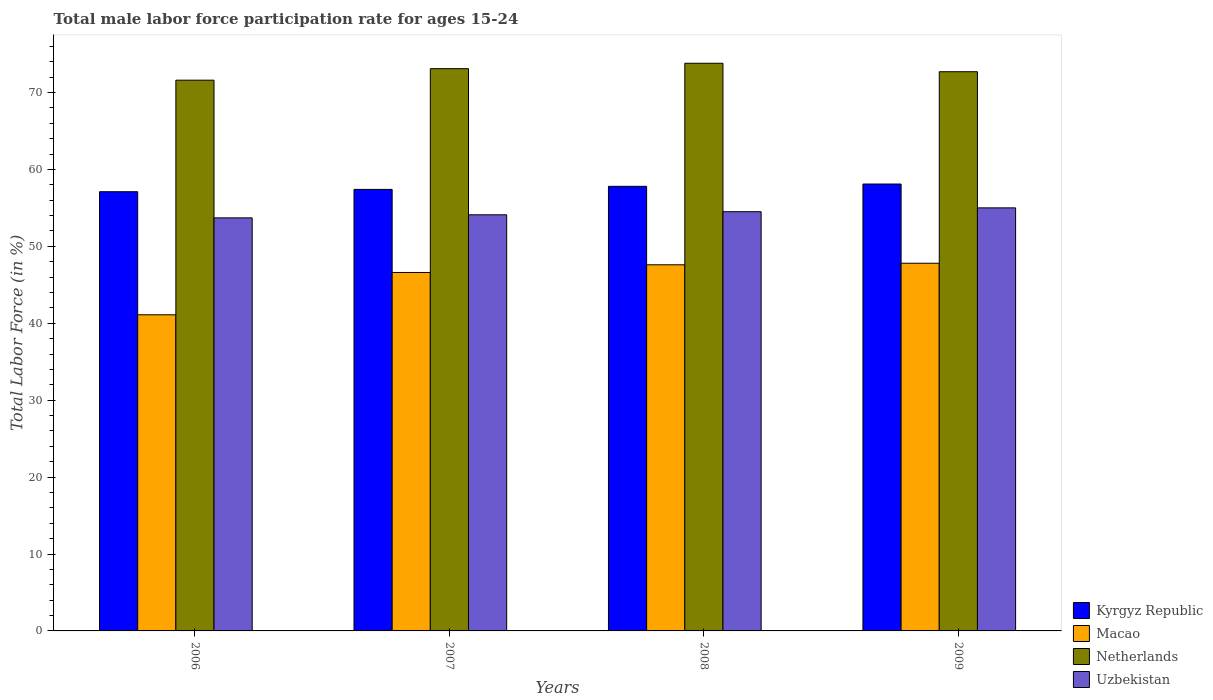How many groups of bars are there?
Your answer should be compact. 4. Are the number of bars on each tick of the X-axis equal?
Make the answer very short. Yes. How many bars are there on the 4th tick from the left?
Ensure brevity in your answer.  4. How many bars are there on the 3rd tick from the right?
Offer a terse response. 4. In how many cases, is the number of bars for a given year not equal to the number of legend labels?
Your answer should be very brief. 0. What is the male labor force participation rate in Netherlands in 2007?
Your answer should be compact. 73.1. Across all years, what is the maximum male labor force participation rate in Macao?
Provide a short and direct response. 47.8. Across all years, what is the minimum male labor force participation rate in Uzbekistan?
Make the answer very short. 53.7. In which year was the male labor force participation rate in Uzbekistan minimum?
Offer a terse response. 2006. What is the total male labor force participation rate in Uzbekistan in the graph?
Make the answer very short. 217.3. What is the difference between the male labor force participation rate in Kyrgyz Republic in 2006 and that in 2007?
Your response must be concise. -0.3. What is the difference between the male labor force participation rate in Uzbekistan in 2007 and the male labor force participation rate in Netherlands in 2006?
Keep it short and to the point. -17.5. What is the average male labor force participation rate in Uzbekistan per year?
Make the answer very short. 54.32. In the year 2006, what is the difference between the male labor force participation rate in Kyrgyz Republic and male labor force participation rate in Netherlands?
Offer a very short reply. -14.5. In how many years, is the male labor force participation rate in Macao greater than 40 %?
Provide a succinct answer. 4. What is the ratio of the male labor force participation rate in Netherlands in 2006 to that in 2007?
Ensure brevity in your answer.  0.98. Is the male labor force participation rate in Kyrgyz Republic in 2006 less than that in 2009?
Offer a very short reply. Yes. Is the difference between the male labor force participation rate in Kyrgyz Republic in 2006 and 2008 greater than the difference between the male labor force participation rate in Netherlands in 2006 and 2008?
Keep it short and to the point. Yes. What is the difference between the highest and the second highest male labor force participation rate in Macao?
Your answer should be compact. 0.2. What is the difference between the highest and the lowest male labor force participation rate in Uzbekistan?
Your response must be concise. 1.3. Is the sum of the male labor force participation rate in Macao in 2007 and 2008 greater than the maximum male labor force participation rate in Netherlands across all years?
Your answer should be compact. Yes. What does the 4th bar from the left in 2006 represents?
Make the answer very short. Uzbekistan. How many bars are there?
Give a very brief answer. 16. Are all the bars in the graph horizontal?
Give a very brief answer. No. Does the graph contain grids?
Make the answer very short. No. What is the title of the graph?
Provide a succinct answer. Total male labor force participation rate for ages 15-24. Does "Rwanda" appear as one of the legend labels in the graph?
Keep it short and to the point. No. What is the label or title of the Y-axis?
Ensure brevity in your answer.  Total Labor Force (in %). What is the Total Labor Force (in %) in Kyrgyz Republic in 2006?
Offer a terse response. 57.1. What is the Total Labor Force (in %) in Macao in 2006?
Ensure brevity in your answer.  41.1. What is the Total Labor Force (in %) of Netherlands in 2006?
Provide a succinct answer. 71.6. What is the Total Labor Force (in %) in Uzbekistan in 2006?
Offer a terse response. 53.7. What is the Total Labor Force (in %) in Kyrgyz Republic in 2007?
Make the answer very short. 57.4. What is the Total Labor Force (in %) in Macao in 2007?
Your answer should be very brief. 46.6. What is the Total Labor Force (in %) of Netherlands in 2007?
Your answer should be compact. 73.1. What is the Total Labor Force (in %) in Uzbekistan in 2007?
Offer a terse response. 54.1. What is the Total Labor Force (in %) in Kyrgyz Republic in 2008?
Make the answer very short. 57.8. What is the Total Labor Force (in %) in Macao in 2008?
Keep it short and to the point. 47.6. What is the Total Labor Force (in %) in Netherlands in 2008?
Your response must be concise. 73.8. What is the Total Labor Force (in %) of Uzbekistan in 2008?
Offer a very short reply. 54.5. What is the Total Labor Force (in %) in Kyrgyz Republic in 2009?
Your answer should be very brief. 58.1. What is the Total Labor Force (in %) of Macao in 2009?
Make the answer very short. 47.8. What is the Total Labor Force (in %) of Netherlands in 2009?
Offer a very short reply. 72.7. What is the Total Labor Force (in %) in Uzbekistan in 2009?
Give a very brief answer. 55. Across all years, what is the maximum Total Labor Force (in %) in Kyrgyz Republic?
Provide a succinct answer. 58.1. Across all years, what is the maximum Total Labor Force (in %) of Macao?
Give a very brief answer. 47.8. Across all years, what is the maximum Total Labor Force (in %) in Netherlands?
Provide a succinct answer. 73.8. Across all years, what is the minimum Total Labor Force (in %) in Kyrgyz Republic?
Ensure brevity in your answer.  57.1. Across all years, what is the minimum Total Labor Force (in %) of Macao?
Your response must be concise. 41.1. Across all years, what is the minimum Total Labor Force (in %) of Netherlands?
Provide a succinct answer. 71.6. Across all years, what is the minimum Total Labor Force (in %) in Uzbekistan?
Make the answer very short. 53.7. What is the total Total Labor Force (in %) in Kyrgyz Republic in the graph?
Your answer should be very brief. 230.4. What is the total Total Labor Force (in %) of Macao in the graph?
Your response must be concise. 183.1. What is the total Total Labor Force (in %) of Netherlands in the graph?
Give a very brief answer. 291.2. What is the total Total Labor Force (in %) of Uzbekistan in the graph?
Your answer should be compact. 217.3. What is the difference between the Total Labor Force (in %) in Uzbekistan in 2006 and that in 2007?
Ensure brevity in your answer.  -0.4. What is the difference between the Total Labor Force (in %) of Kyrgyz Republic in 2006 and that in 2008?
Offer a very short reply. -0.7. What is the difference between the Total Labor Force (in %) of Macao in 2006 and that in 2008?
Your answer should be very brief. -6.5. What is the difference between the Total Labor Force (in %) of Uzbekistan in 2006 and that in 2008?
Keep it short and to the point. -0.8. What is the difference between the Total Labor Force (in %) of Kyrgyz Republic in 2006 and that in 2009?
Offer a very short reply. -1. What is the difference between the Total Labor Force (in %) in Macao in 2006 and that in 2009?
Make the answer very short. -6.7. What is the difference between the Total Labor Force (in %) in Kyrgyz Republic in 2007 and that in 2008?
Offer a very short reply. -0.4. What is the difference between the Total Labor Force (in %) of Netherlands in 2007 and that in 2008?
Your answer should be very brief. -0.7. What is the difference between the Total Labor Force (in %) of Uzbekistan in 2007 and that in 2008?
Offer a very short reply. -0.4. What is the difference between the Total Labor Force (in %) in Kyrgyz Republic in 2007 and that in 2009?
Give a very brief answer. -0.7. What is the difference between the Total Labor Force (in %) in Macao in 2007 and that in 2009?
Give a very brief answer. -1.2. What is the difference between the Total Labor Force (in %) of Uzbekistan in 2007 and that in 2009?
Offer a terse response. -0.9. What is the difference between the Total Labor Force (in %) of Netherlands in 2008 and that in 2009?
Ensure brevity in your answer.  1.1. What is the difference between the Total Labor Force (in %) of Uzbekistan in 2008 and that in 2009?
Ensure brevity in your answer.  -0.5. What is the difference between the Total Labor Force (in %) in Kyrgyz Republic in 2006 and the Total Labor Force (in %) in Netherlands in 2007?
Offer a terse response. -16. What is the difference between the Total Labor Force (in %) in Macao in 2006 and the Total Labor Force (in %) in Netherlands in 2007?
Your answer should be compact. -32. What is the difference between the Total Labor Force (in %) of Macao in 2006 and the Total Labor Force (in %) of Uzbekistan in 2007?
Give a very brief answer. -13. What is the difference between the Total Labor Force (in %) in Kyrgyz Republic in 2006 and the Total Labor Force (in %) in Netherlands in 2008?
Ensure brevity in your answer.  -16.7. What is the difference between the Total Labor Force (in %) in Macao in 2006 and the Total Labor Force (in %) in Netherlands in 2008?
Ensure brevity in your answer.  -32.7. What is the difference between the Total Labor Force (in %) in Macao in 2006 and the Total Labor Force (in %) in Uzbekistan in 2008?
Keep it short and to the point. -13.4. What is the difference between the Total Labor Force (in %) of Kyrgyz Republic in 2006 and the Total Labor Force (in %) of Netherlands in 2009?
Your answer should be very brief. -15.6. What is the difference between the Total Labor Force (in %) of Macao in 2006 and the Total Labor Force (in %) of Netherlands in 2009?
Provide a succinct answer. -31.6. What is the difference between the Total Labor Force (in %) in Macao in 2006 and the Total Labor Force (in %) in Uzbekistan in 2009?
Ensure brevity in your answer.  -13.9. What is the difference between the Total Labor Force (in %) in Kyrgyz Republic in 2007 and the Total Labor Force (in %) in Netherlands in 2008?
Your response must be concise. -16.4. What is the difference between the Total Labor Force (in %) in Macao in 2007 and the Total Labor Force (in %) in Netherlands in 2008?
Ensure brevity in your answer.  -27.2. What is the difference between the Total Labor Force (in %) in Macao in 2007 and the Total Labor Force (in %) in Uzbekistan in 2008?
Your response must be concise. -7.9. What is the difference between the Total Labor Force (in %) of Kyrgyz Republic in 2007 and the Total Labor Force (in %) of Netherlands in 2009?
Provide a short and direct response. -15.3. What is the difference between the Total Labor Force (in %) in Macao in 2007 and the Total Labor Force (in %) in Netherlands in 2009?
Give a very brief answer. -26.1. What is the difference between the Total Labor Force (in %) of Netherlands in 2007 and the Total Labor Force (in %) of Uzbekistan in 2009?
Keep it short and to the point. 18.1. What is the difference between the Total Labor Force (in %) of Kyrgyz Republic in 2008 and the Total Labor Force (in %) of Macao in 2009?
Your answer should be very brief. 10. What is the difference between the Total Labor Force (in %) of Kyrgyz Republic in 2008 and the Total Labor Force (in %) of Netherlands in 2009?
Make the answer very short. -14.9. What is the difference between the Total Labor Force (in %) in Macao in 2008 and the Total Labor Force (in %) in Netherlands in 2009?
Your response must be concise. -25.1. What is the difference between the Total Labor Force (in %) in Macao in 2008 and the Total Labor Force (in %) in Uzbekistan in 2009?
Ensure brevity in your answer.  -7.4. What is the average Total Labor Force (in %) of Kyrgyz Republic per year?
Ensure brevity in your answer.  57.6. What is the average Total Labor Force (in %) of Macao per year?
Provide a succinct answer. 45.77. What is the average Total Labor Force (in %) of Netherlands per year?
Offer a very short reply. 72.8. What is the average Total Labor Force (in %) in Uzbekistan per year?
Give a very brief answer. 54.33. In the year 2006, what is the difference between the Total Labor Force (in %) of Kyrgyz Republic and Total Labor Force (in %) of Macao?
Give a very brief answer. 16. In the year 2006, what is the difference between the Total Labor Force (in %) in Macao and Total Labor Force (in %) in Netherlands?
Ensure brevity in your answer.  -30.5. In the year 2006, what is the difference between the Total Labor Force (in %) of Macao and Total Labor Force (in %) of Uzbekistan?
Offer a very short reply. -12.6. In the year 2007, what is the difference between the Total Labor Force (in %) of Kyrgyz Republic and Total Labor Force (in %) of Macao?
Provide a succinct answer. 10.8. In the year 2007, what is the difference between the Total Labor Force (in %) of Kyrgyz Republic and Total Labor Force (in %) of Netherlands?
Provide a succinct answer. -15.7. In the year 2007, what is the difference between the Total Labor Force (in %) of Macao and Total Labor Force (in %) of Netherlands?
Your answer should be very brief. -26.5. In the year 2008, what is the difference between the Total Labor Force (in %) in Kyrgyz Republic and Total Labor Force (in %) in Macao?
Your answer should be very brief. 10.2. In the year 2008, what is the difference between the Total Labor Force (in %) of Kyrgyz Republic and Total Labor Force (in %) of Netherlands?
Keep it short and to the point. -16. In the year 2008, what is the difference between the Total Labor Force (in %) in Macao and Total Labor Force (in %) in Netherlands?
Offer a very short reply. -26.2. In the year 2008, what is the difference between the Total Labor Force (in %) of Macao and Total Labor Force (in %) of Uzbekistan?
Provide a succinct answer. -6.9. In the year 2008, what is the difference between the Total Labor Force (in %) in Netherlands and Total Labor Force (in %) in Uzbekistan?
Keep it short and to the point. 19.3. In the year 2009, what is the difference between the Total Labor Force (in %) of Kyrgyz Republic and Total Labor Force (in %) of Netherlands?
Provide a succinct answer. -14.6. In the year 2009, what is the difference between the Total Labor Force (in %) in Kyrgyz Republic and Total Labor Force (in %) in Uzbekistan?
Give a very brief answer. 3.1. In the year 2009, what is the difference between the Total Labor Force (in %) in Macao and Total Labor Force (in %) in Netherlands?
Make the answer very short. -24.9. In the year 2009, what is the difference between the Total Labor Force (in %) in Macao and Total Labor Force (in %) in Uzbekistan?
Offer a very short reply. -7.2. In the year 2009, what is the difference between the Total Labor Force (in %) in Netherlands and Total Labor Force (in %) in Uzbekistan?
Your response must be concise. 17.7. What is the ratio of the Total Labor Force (in %) of Macao in 2006 to that in 2007?
Your answer should be very brief. 0.88. What is the ratio of the Total Labor Force (in %) in Netherlands in 2006 to that in 2007?
Make the answer very short. 0.98. What is the ratio of the Total Labor Force (in %) in Uzbekistan in 2006 to that in 2007?
Make the answer very short. 0.99. What is the ratio of the Total Labor Force (in %) of Kyrgyz Republic in 2006 to that in 2008?
Keep it short and to the point. 0.99. What is the ratio of the Total Labor Force (in %) in Macao in 2006 to that in 2008?
Your response must be concise. 0.86. What is the ratio of the Total Labor Force (in %) in Netherlands in 2006 to that in 2008?
Provide a succinct answer. 0.97. What is the ratio of the Total Labor Force (in %) of Uzbekistan in 2006 to that in 2008?
Provide a succinct answer. 0.99. What is the ratio of the Total Labor Force (in %) of Kyrgyz Republic in 2006 to that in 2009?
Offer a very short reply. 0.98. What is the ratio of the Total Labor Force (in %) of Macao in 2006 to that in 2009?
Offer a terse response. 0.86. What is the ratio of the Total Labor Force (in %) of Netherlands in 2006 to that in 2009?
Your response must be concise. 0.98. What is the ratio of the Total Labor Force (in %) in Uzbekistan in 2006 to that in 2009?
Provide a succinct answer. 0.98. What is the ratio of the Total Labor Force (in %) in Netherlands in 2007 to that in 2008?
Offer a very short reply. 0.99. What is the ratio of the Total Labor Force (in %) of Kyrgyz Republic in 2007 to that in 2009?
Your answer should be very brief. 0.99. What is the ratio of the Total Labor Force (in %) in Macao in 2007 to that in 2009?
Keep it short and to the point. 0.97. What is the ratio of the Total Labor Force (in %) of Uzbekistan in 2007 to that in 2009?
Your response must be concise. 0.98. What is the ratio of the Total Labor Force (in %) of Kyrgyz Republic in 2008 to that in 2009?
Ensure brevity in your answer.  0.99. What is the ratio of the Total Labor Force (in %) in Macao in 2008 to that in 2009?
Keep it short and to the point. 1. What is the ratio of the Total Labor Force (in %) in Netherlands in 2008 to that in 2009?
Your response must be concise. 1.02. What is the ratio of the Total Labor Force (in %) of Uzbekistan in 2008 to that in 2009?
Provide a succinct answer. 0.99. What is the difference between the highest and the second highest Total Labor Force (in %) in Kyrgyz Republic?
Provide a short and direct response. 0.3. What is the difference between the highest and the second highest Total Labor Force (in %) of Netherlands?
Offer a very short reply. 0.7. What is the difference between the highest and the second highest Total Labor Force (in %) in Uzbekistan?
Your answer should be very brief. 0.5. What is the difference between the highest and the lowest Total Labor Force (in %) of Macao?
Offer a terse response. 6.7. 